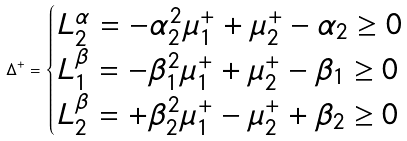Convert formula to latex. <formula><loc_0><loc_0><loc_500><loc_500>\Delta ^ { + } = \begin{cases} L _ { 2 } ^ { \alpha } = - \alpha _ { 2 } ^ { 2 } \mu _ { 1 } ^ { + } + \mu _ { 2 } ^ { + } - \alpha _ { 2 } \geq 0 \\ L _ { 1 } ^ { \beta } = - \beta _ { 1 } ^ { 2 } \mu _ { 1 } ^ { + } + \mu _ { 2 } ^ { + } - \beta _ { 1 } \geq 0 \\ L _ { 2 } ^ { \beta } = + \beta _ { 2 } ^ { 2 } \mu _ { 1 } ^ { + } - \mu _ { 2 } ^ { + } + \beta _ { 2 } \geq 0 \end{cases}</formula> 